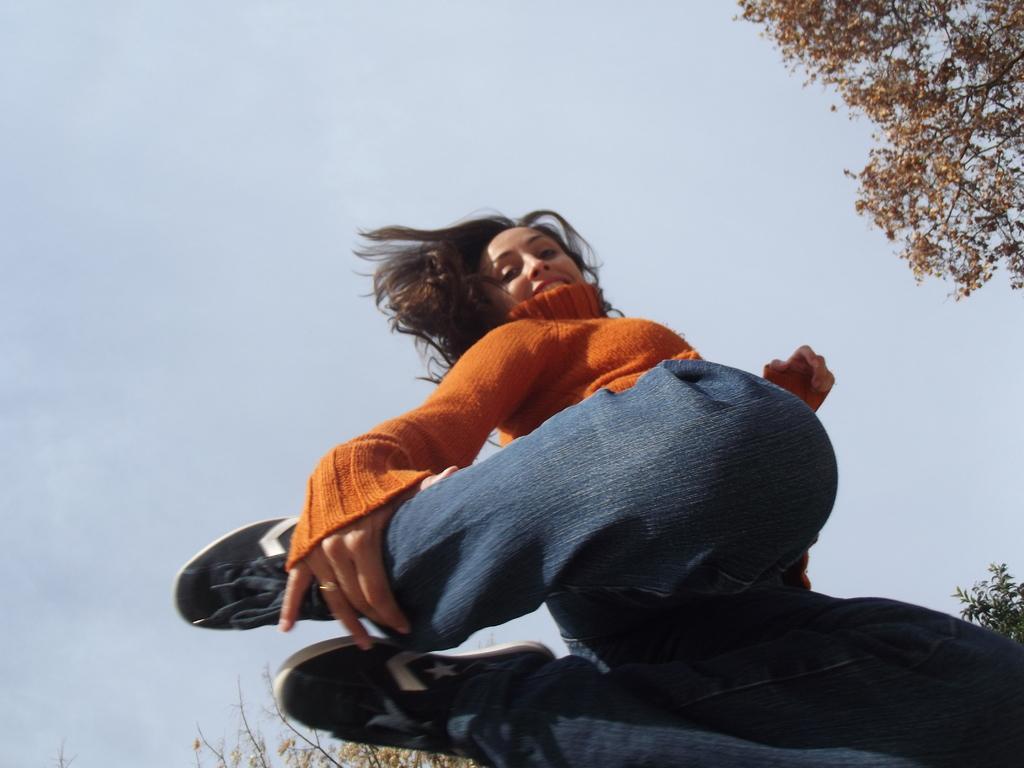Please provide a concise description of this image. In this image I can see a woman wearing orange t shirt, blue jeans and black shoe and in the background I can see few trees and the sky. 